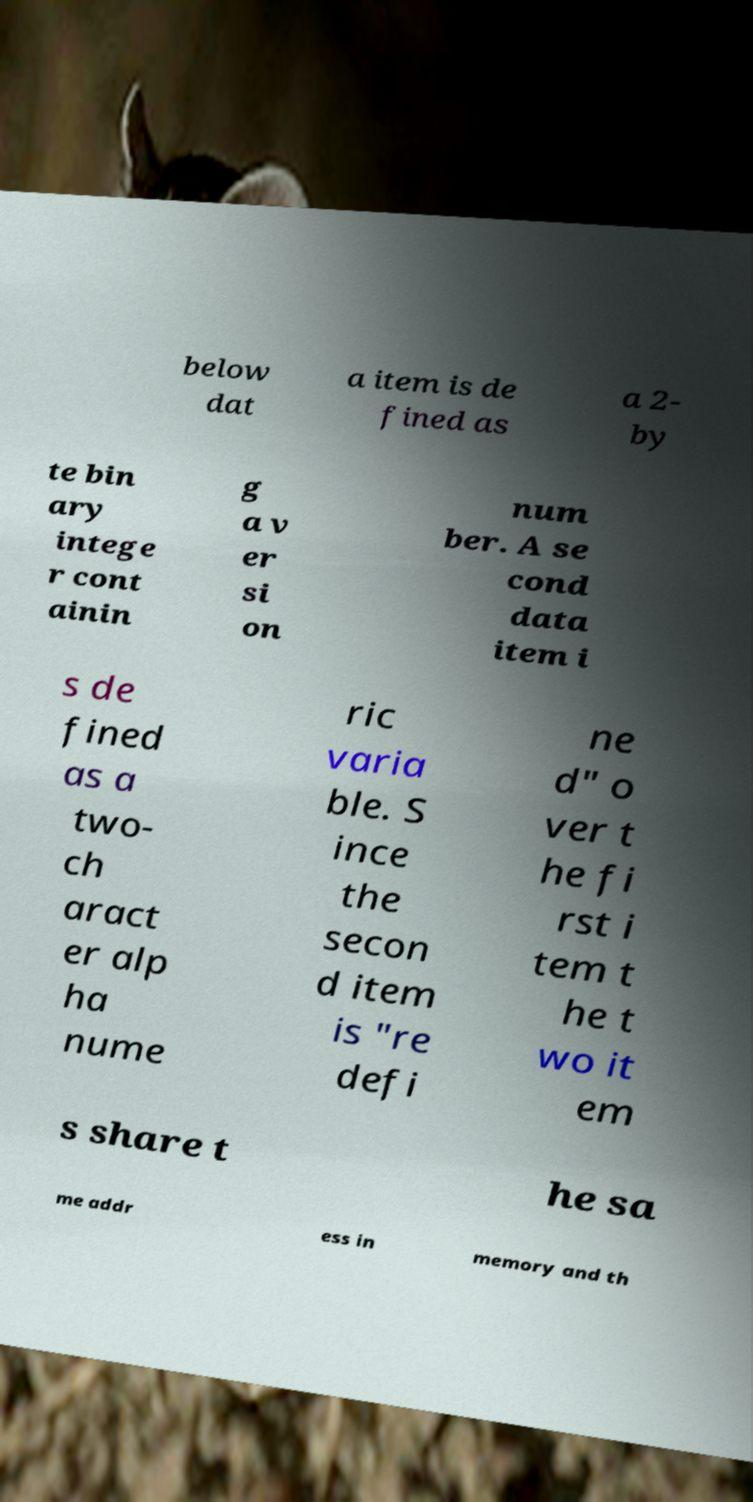What messages or text are displayed in this image? I need them in a readable, typed format. below dat a item is de fined as a 2- by te bin ary intege r cont ainin g a v er si on num ber. A se cond data item i s de fined as a two- ch aract er alp ha nume ric varia ble. S ince the secon d item is "re defi ne d" o ver t he fi rst i tem t he t wo it em s share t he sa me addr ess in memory and th 